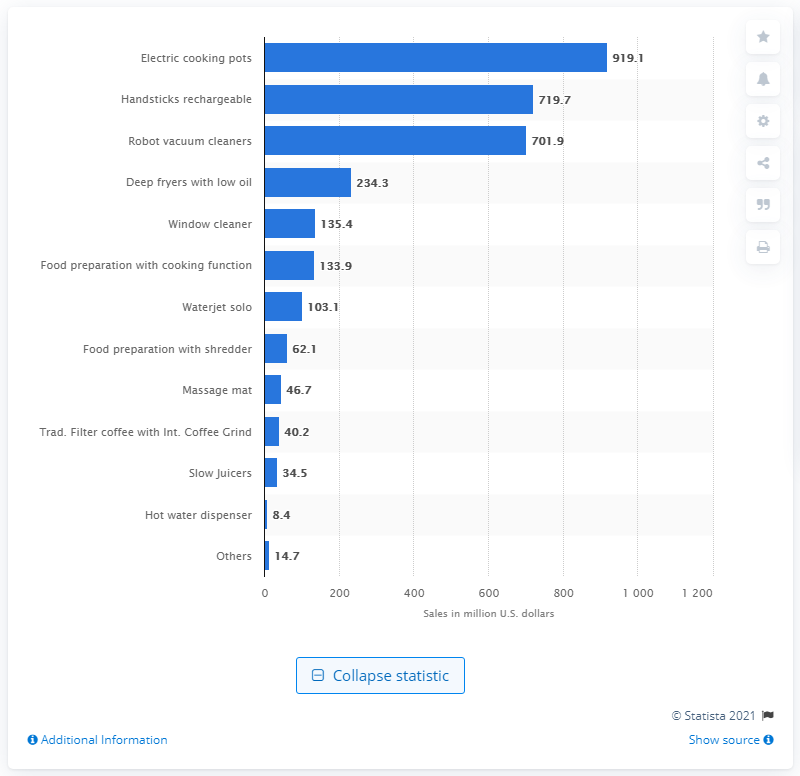Outline some significant characteristics in this image. In 2013, the electric cooking pot market generated $919.1 million in the United States. 